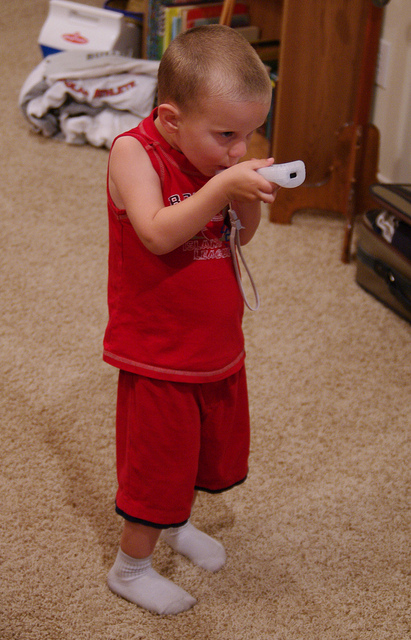<image>What animal is on the boys shorts? There is no animal on the boy's shorts. What animal is on the boys shorts? There is no animal on the boy's shorts. 